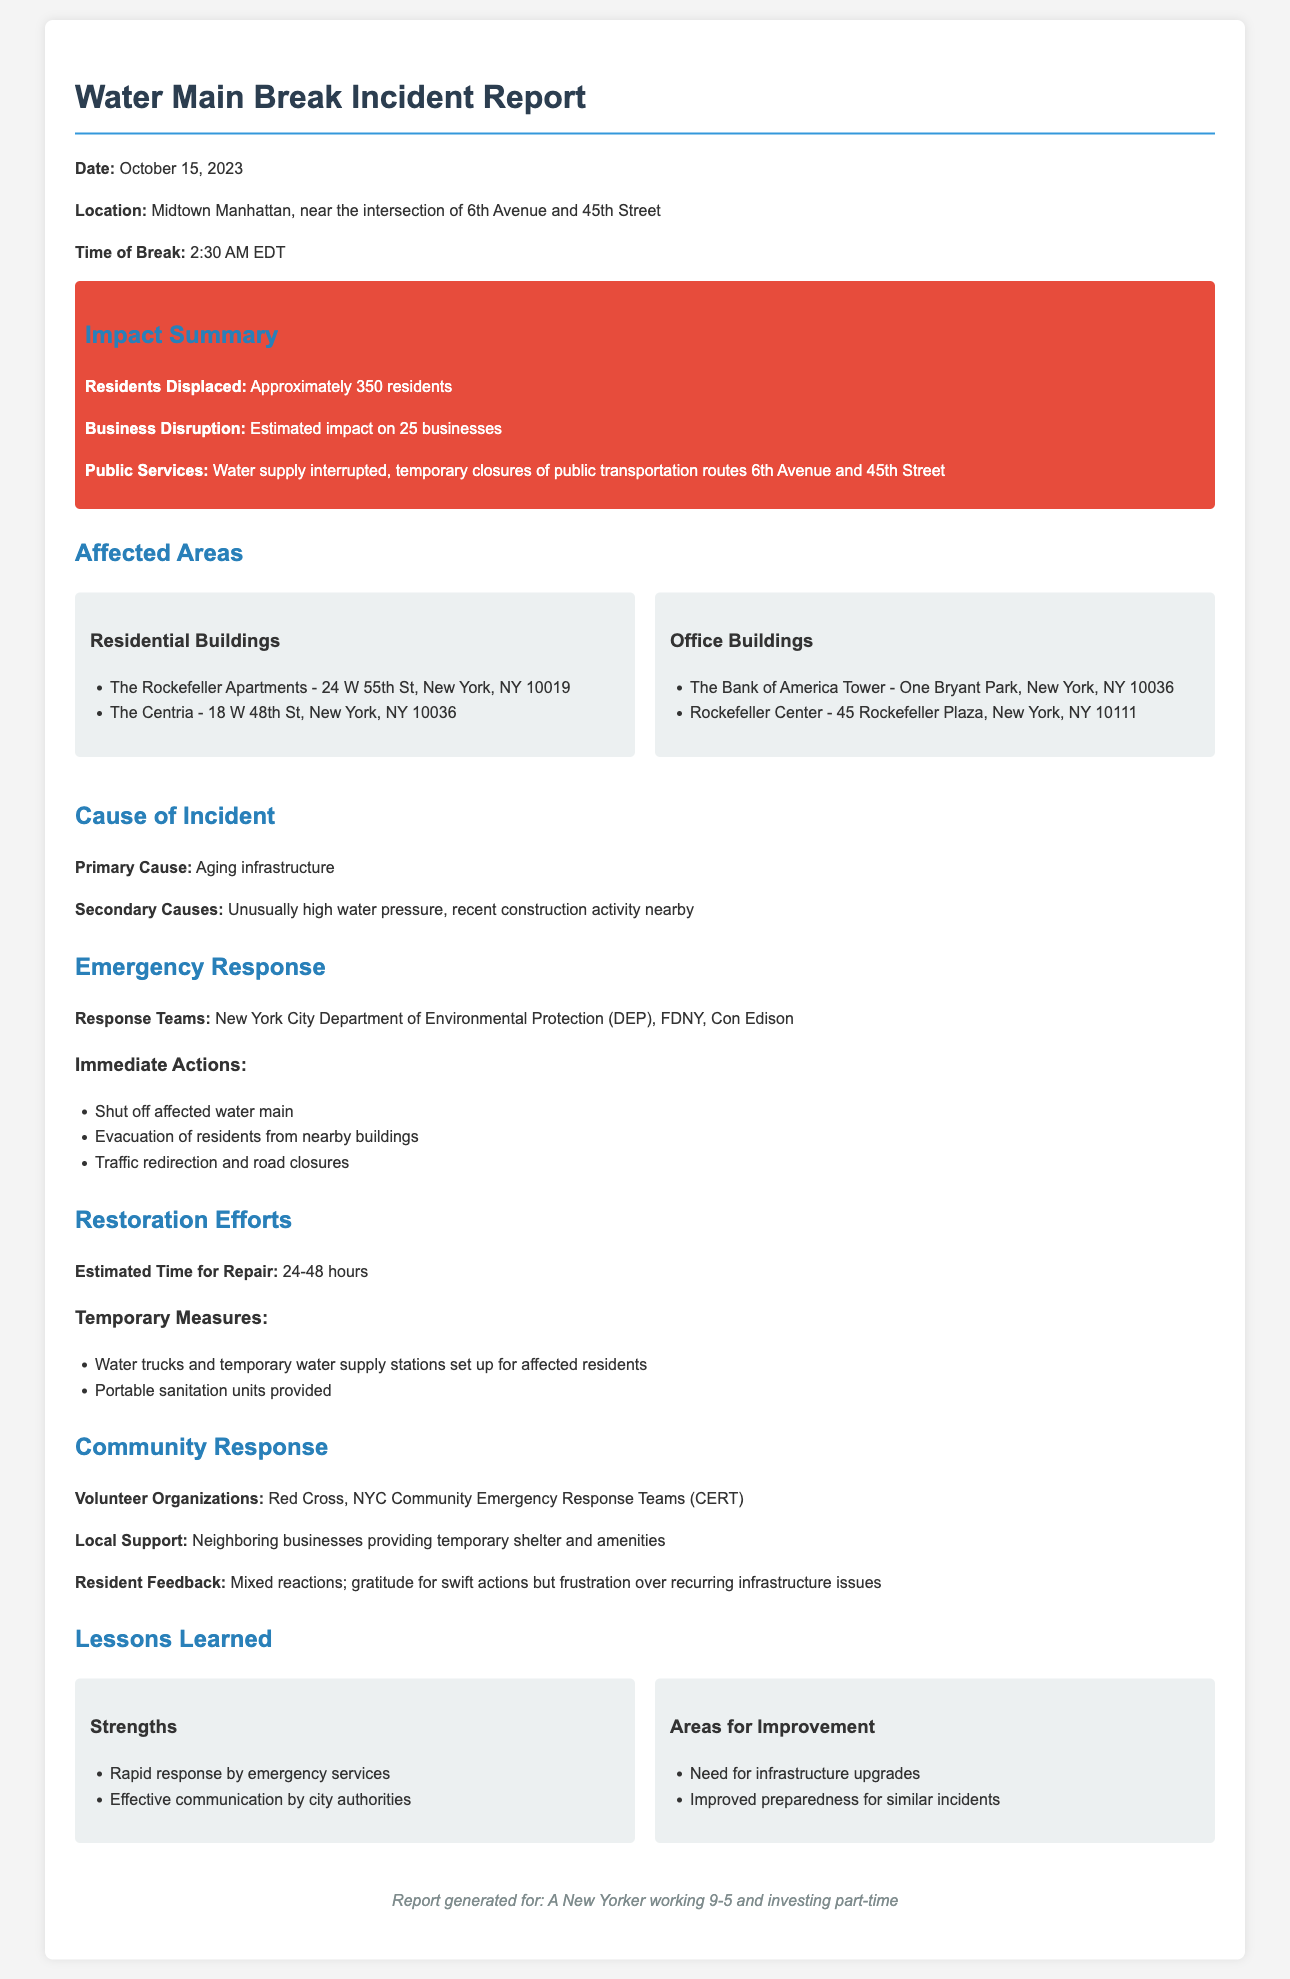What is the date of the incident? The date of the incident report is stated clearly as October 15, 2023.
Answer: October 15, 2023 How many residents were displaced? The document mentions that approximately 350 residents were displaced due to the water main break.
Answer: Approximately 350 residents What are the names of one residential and one office building affected? The report lists several affected buildings; one residential is The Rockefeller Apartments and one office is The Bank of America Tower.
Answer: The Rockefeller Apartments and The Bank of America Tower What was the primary cause of the incident? The primary cause of the water main break is identified as aging infrastructure in the document.
Answer: Aging infrastructure What was the estimated time for repair? The report states that the estimated time for repair is between 24 to 48 hours.
Answer: 24-48 hours What organizations are helping the community? The report names the Red Cross and NYC Community Emergency Response Teams (CERT) as the volunteer organizations helping the community.
Answer: Red Cross, NYC Community Emergency Response Teams (CERT) What emergency services responded to the incident? The response teams mentioned include the New York City Department of Environmental Protection (DEP), FDNY, and Con Edison.
Answer: New York City Department of Environmental Protection (DEP), FDNY, Con Edison What were the immediate actions taken? The document lists several immediate actions, including shutting off the affected water main, evacuating residents, and redirecting traffic.
Answer: Shut off affected water main, evacuation of residents, traffic redirection What is a lesson learned in terms of strengths? The report highlights rapid response by emergency services as one of the strengths learned from the incident.
Answer: Rapid response by emergency services 